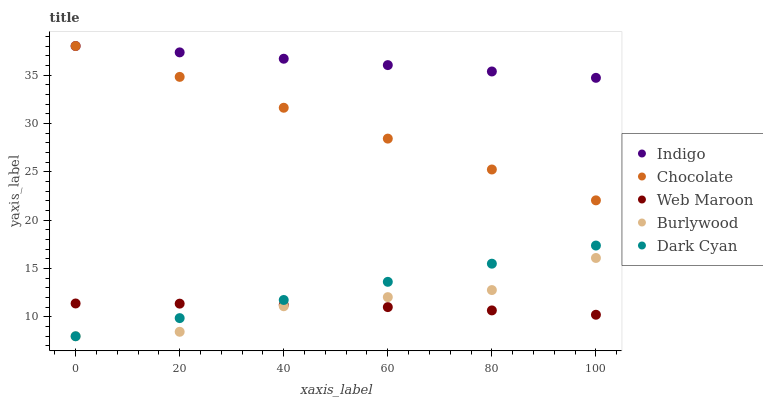Does Web Maroon have the minimum area under the curve?
Answer yes or no. Yes. Does Indigo have the maximum area under the curve?
Answer yes or no. Yes. Does Indigo have the minimum area under the curve?
Answer yes or no. No. Does Web Maroon have the maximum area under the curve?
Answer yes or no. No. Is Dark Cyan the smoothest?
Answer yes or no. Yes. Is Burlywood the roughest?
Answer yes or no. Yes. Is Web Maroon the smoothest?
Answer yes or no. No. Is Web Maroon the roughest?
Answer yes or no. No. Does Burlywood have the lowest value?
Answer yes or no. Yes. Does Web Maroon have the lowest value?
Answer yes or no. No. Does Chocolate have the highest value?
Answer yes or no. Yes. Does Web Maroon have the highest value?
Answer yes or no. No. Is Burlywood less than Indigo?
Answer yes or no. Yes. Is Indigo greater than Web Maroon?
Answer yes or no. Yes. Does Web Maroon intersect Burlywood?
Answer yes or no. Yes. Is Web Maroon less than Burlywood?
Answer yes or no. No. Is Web Maroon greater than Burlywood?
Answer yes or no. No. Does Burlywood intersect Indigo?
Answer yes or no. No. 